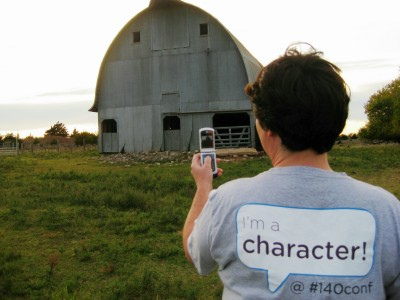Read all the text in this image. I'm a charater 140 conf @ 